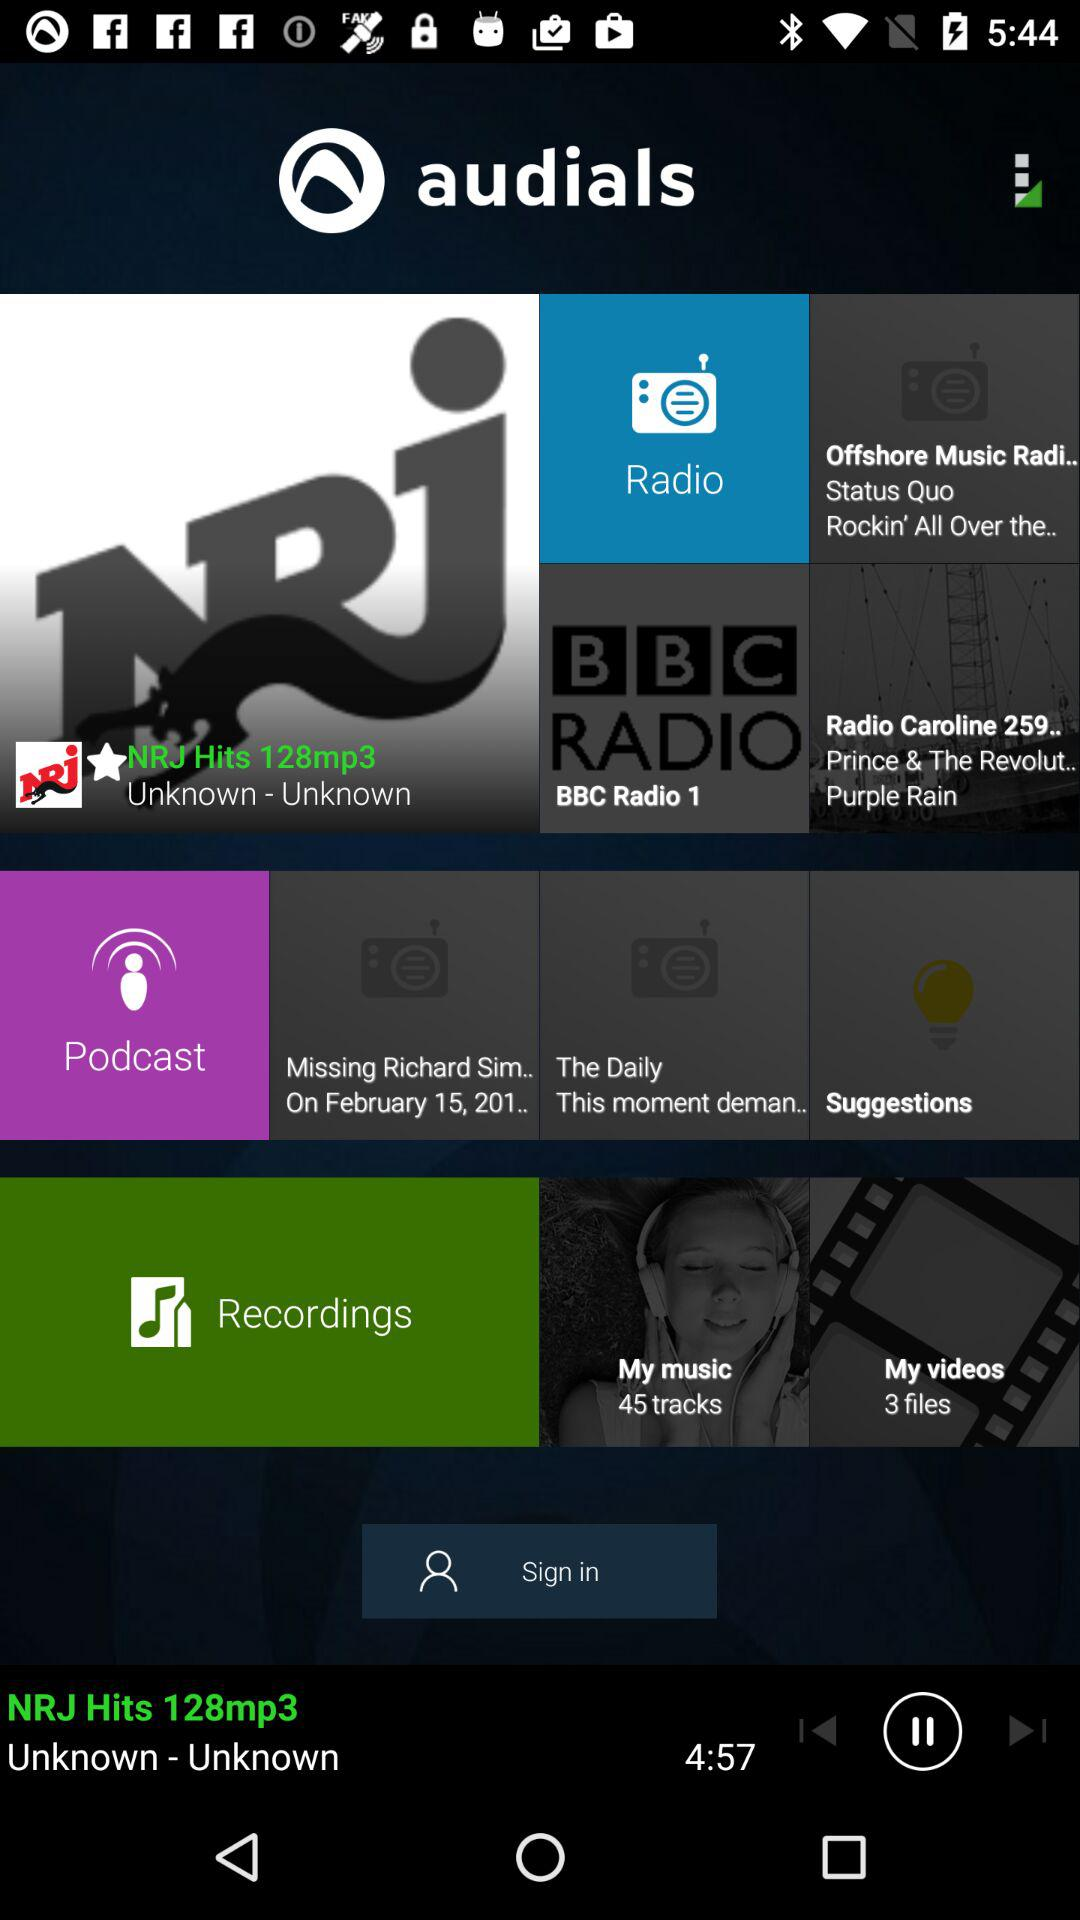Which song is playing? The song "NRJ Hits 128mp3" is playing. 